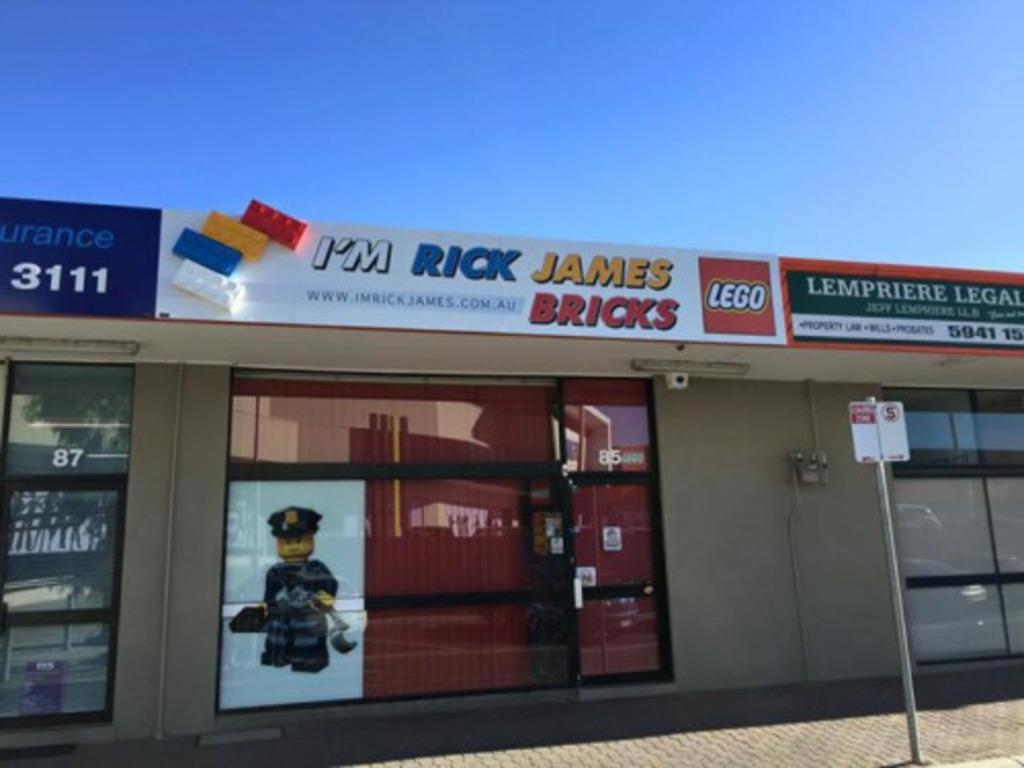Could you give a brief overview of what you see in this image? In the foreground of the image we can see the platform. In the middle of the image we can see a pole, board, shops and a text written on it. On the top of the image we can see the sky. 